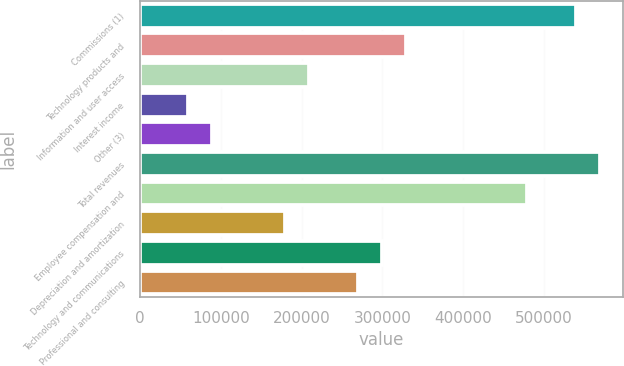<chart> <loc_0><loc_0><loc_500><loc_500><bar_chart><fcel>Commissions (1)<fcel>Technology products and<fcel>Information and user access<fcel>Interest income<fcel>Other (3)<fcel>Total revenues<fcel>Employee compensation and<fcel>Depreciation and amortization<fcel>Technology and communications<fcel>Professional and consulting<nl><fcel>539137<fcel>329473<fcel>209665<fcel>59904.8<fcel>89856.9<fcel>569089<fcel>479233<fcel>179713<fcel>299521<fcel>269569<nl></chart> 